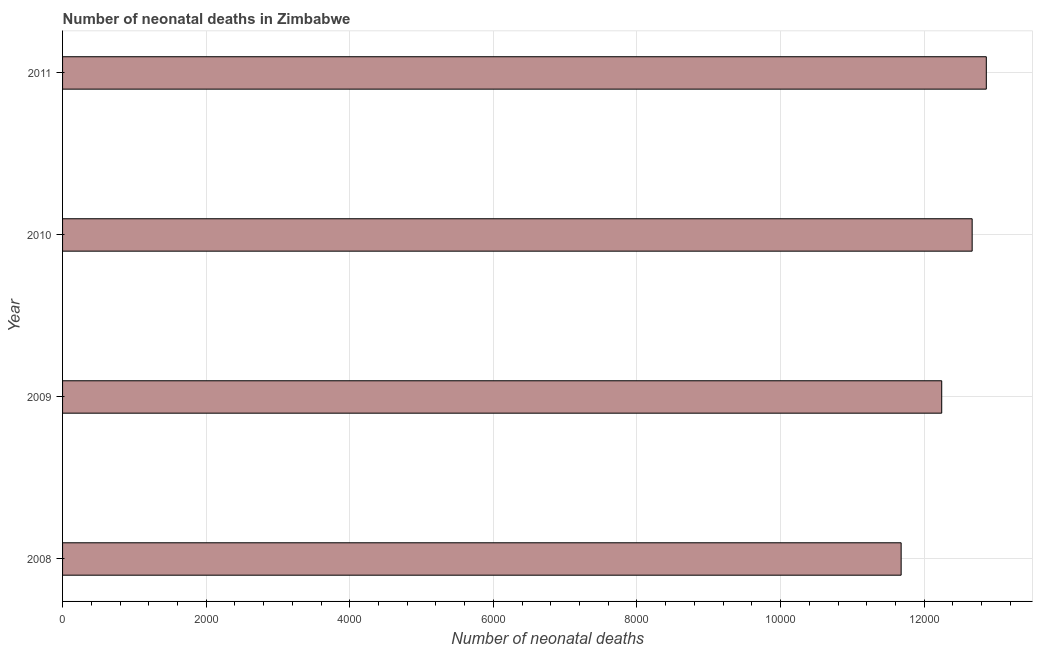Does the graph contain any zero values?
Your answer should be compact. No. Does the graph contain grids?
Ensure brevity in your answer.  Yes. What is the title of the graph?
Your answer should be compact. Number of neonatal deaths in Zimbabwe. What is the label or title of the X-axis?
Offer a terse response. Number of neonatal deaths. What is the label or title of the Y-axis?
Your answer should be very brief. Year. What is the number of neonatal deaths in 2009?
Your response must be concise. 1.22e+04. Across all years, what is the maximum number of neonatal deaths?
Keep it short and to the point. 1.29e+04. Across all years, what is the minimum number of neonatal deaths?
Keep it short and to the point. 1.17e+04. What is the sum of the number of neonatal deaths?
Provide a short and direct response. 4.95e+04. What is the difference between the number of neonatal deaths in 2009 and 2010?
Offer a terse response. -424. What is the average number of neonatal deaths per year?
Offer a terse response. 1.24e+04. What is the median number of neonatal deaths?
Keep it short and to the point. 1.25e+04. What is the ratio of the number of neonatal deaths in 2009 to that in 2011?
Your answer should be compact. 0.95. Is the number of neonatal deaths in 2008 less than that in 2010?
Provide a short and direct response. Yes. What is the difference between the highest and the second highest number of neonatal deaths?
Provide a short and direct response. 197. Is the sum of the number of neonatal deaths in 2008 and 2011 greater than the maximum number of neonatal deaths across all years?
Offer a very short reply. Yes. What is the difference between the highest and the lowest number of neonatal deaths?
Your answer should be very brief. 1186. In how many years, is the number of neonatal deaths greater than the average number of neonatal deaths taken over all years?
Ensure brevity in your answer.  2. What is the difference between two consecutive major ticks on the X-axis?
Offer a terse response. 2000. What is the Number of neonatal deaths of 2008?
Your answer should be very brief. 1.17e+04. What is the Number of neonatal deaths of 2009?
Your response must be concise. 1.22e+04. What is the Number of neonatal deaths of 2010?
Make the answer very short. 1.27e+04. What is the Number of neonatal deaths in 2011?
Offer a terse response. 1.29e+04. What is the difference between the Number of neonatal deaths in 2008 and 2009?
Your answer should be compact. -565. What is the difference between the Number of neonatal deaths in 2008 and 2010?
Provide a short and direct response. -989. What is the difference between the Number of neonatal deaths in 2008 and 2011?
Offer a terse response. -1186. What is the difference between the Number of neonatal deaths in 2009 and 2010?
Your response must be concise. -424. What is the difference between the Number of neonatal deaths in 2009 and 2011?
Ensure brevity in your answer.  -621. What is the difference between the Number of neonatal deaths in 2010 and 2011?
Your answer should be very brief. -197. What is the ratio of the Number of neonatal deaths in 2008 to that in 2009?
Provide a short and direct response. 0.95. What is the ratio of the Number of neonatal deaths in 2008 to that in 2010?
Make the answer very short. 0.92. What is the ratio of the Number of neonatal deaths in 2008 to that in 2011?
Offer a very short reply. 0.91. What is the ratio of the Number of neonatal deaths in 2009 to that in 2010?
Your answer should be very brief. 0.97. What is the ratio of the Number of neonatal deaths in 2010 to that in 2011?
Offer a terse response. 0.98. 